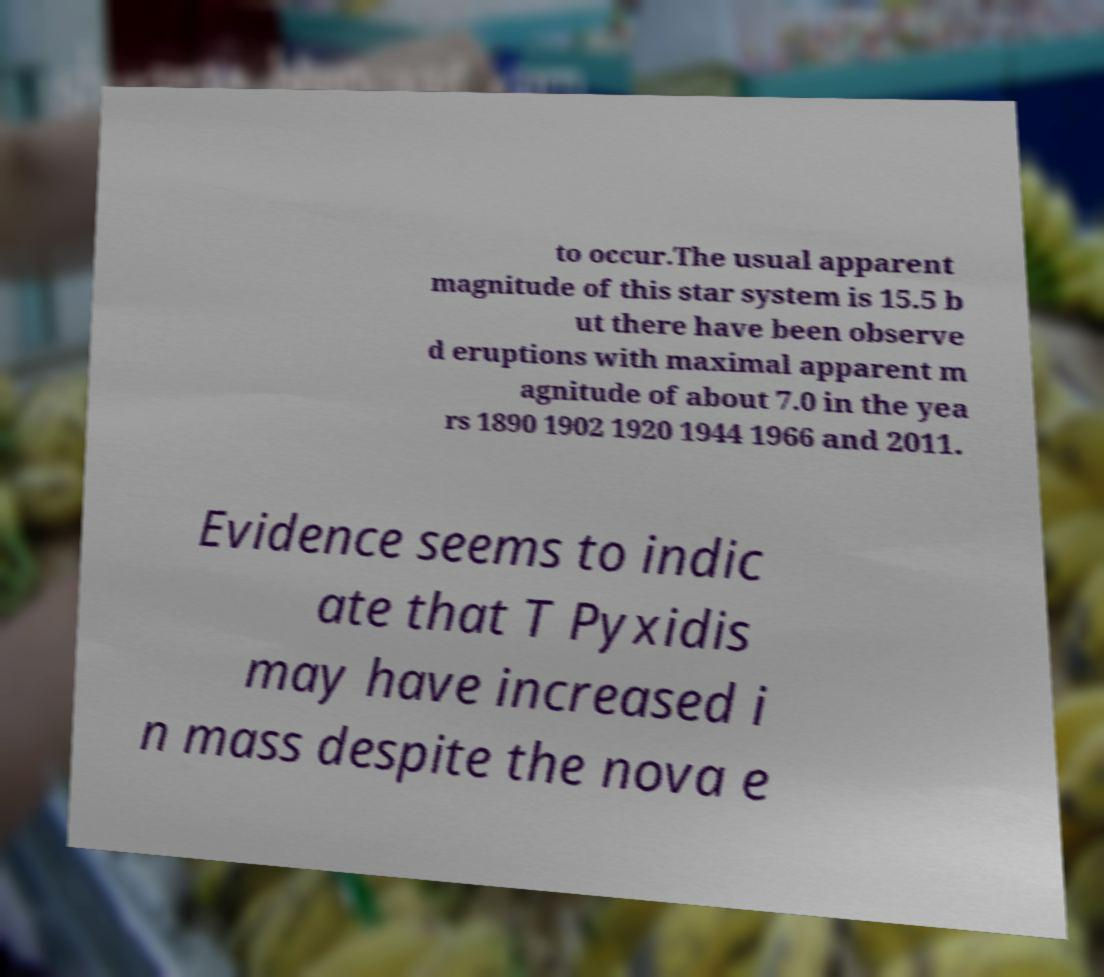Can you read and provide the text displayed in the image?This photo seems to have some interesting text. Can you extract and type it out for me? to occur.The usual apparent magnitude of this star system is 15.5 b ut there have been observe d eruptions with maximal apparent m agnitude of about 7.0 in the yea rs 1890 1902 1920 1944 1966 and 2011. Evidence seems to indic ate that T Pyxidis may have increased i n mass despite the nova e 